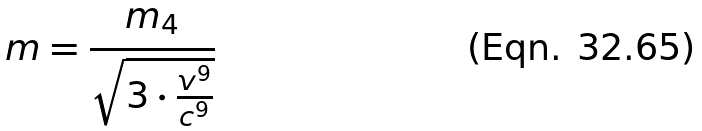Convert formula to latex. <formula><loc_0><loc_0><loc_500><loc_500>m = \frac { m _ { 4 } } { \sqrt { 3 \cdot \frac { v ^ { 9 } } { c ^ { 9 } } } }</formula> 